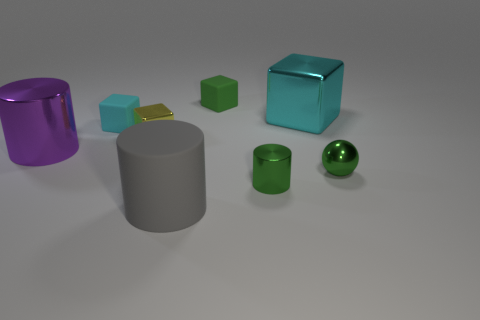How many objects are there in the image, and can you describe them? There are seven objects in the image, including a purple cylinder, a small yellow cuboid, a green matte cube, a cyan glossy cube, a gray cylinder, a small green cuboid, and a shiny green sphere.  Which object appears to be in the foreground? The gray cylinder appears to be in the foreground due to its placement and size relative to the other objects. 